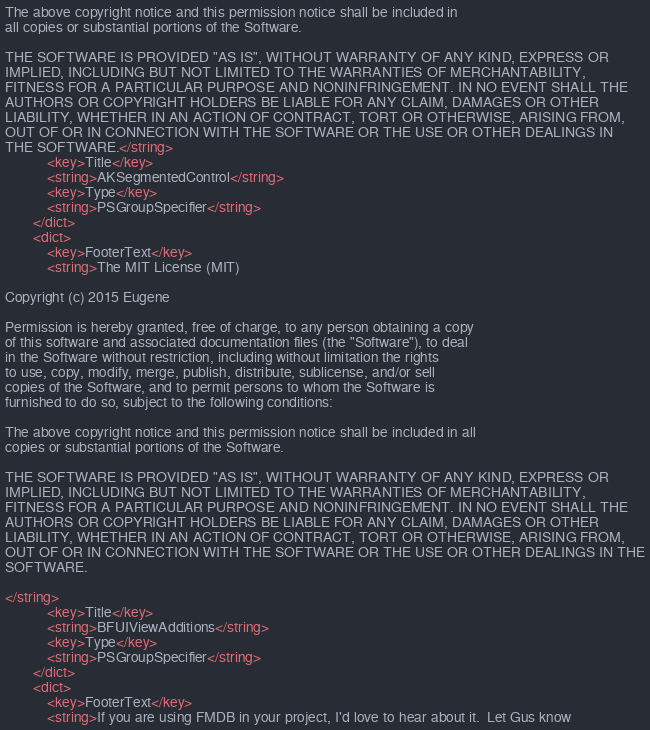<code> <loc_0><loc_0><loc_500><loc_500><_XML_>The above copyright notice and this permission notice shall be included in
all copies or substantial portions of the Software.

THE SOFTWARE IS PROVIDED "AS IS", WITHOUT WARRANTY OF ANY KIND, EXPRESS OR
IMPLIED, INCLUDING BUT NOT LIMITED TO THE WARRANTIES OF MERCHANTABILITY,
FITNESS FOR A PARTICULAR PURPOSE AND NONINFRINGEMENT. IN NO EVENT SHALL THE
AUTHORS OR COPYRIGHT HOLDERS BE LIABLE FOR ANY CLAIM, DAMAGES OR OTHER
LIABILITY, WHETHER IN AN ACTION OF CONTRACT, TORT OR OTHERWISE, ARISING FROM,
OUT OF OR IN CONNECTION WITH THE SOFTWARE OR THE USE OR OTHER DEALINGS IN
THE SOFTWARE.</string>
			<key>Title</key>
			<string>AKSegmentedControl</string>
			<key>Type</key>
			<string>PSGroupSpecifier</string>
		</dict>
		<dict>
			<key>FooterText</key>
			<string>The MIT License (MIT)

Copyright (c) 2015 Eugene

Permission is hereby granted, free of charge, to any person obtaining a copy
of this software and associated documentation files (the "Software"), to deal
in the Software without restriction, including without limitation the rights
to use, copy, modify, merge, publish, distribute, sublicense, and/or sell
copies of the Software, and to permit persons to whom the Software is
furnished to do so, subject to the following conditions:

The above copyright notice and this permission notice shall be included in all
copies or substantial portions of the Software.

THE SOFTWARE IS PROVIDED "AS IS", WITHOUT WARRANTY OF ANY KIND, EXPRESS OR
IMPLIED, INCLUDING BUT NOT LIMITED TO THE WARRANTIES OF MERCHANTABILITY,
FITNESS FOR A PARTICULAR PURPOSE AND NONINFRINGEMENT. IN NO EVENT SHALL THE
AUTHORS OR COPYRIGHT HOLDERS BE LIABLE FOR ANY CLAIM, DAMAGES OR OTHER
LIABILITY, WHETHER IN AN ACTION OF CONTRACT, TORT OR OTHERWISE, ARISING FROM,
OUT OF OR IN CONNECTION WITH THE SOFTWARE OR THE USE OR OTHER DEALINGS IN THE
SOFTWARE.

</string>
			<key>Title</key>
			<string>BFUIViewAdditions</string>
			<key>Type</key>
			<string>PSGroupSpecifier</string>
		</dict>
		<dict>
			<key>FooterText</key>
			<string>If you are using FMDB in your project, I'd love to hear about it.  Let Gus know</code> 